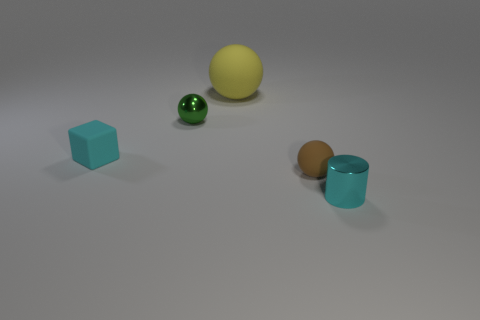Is the color of the sphere behind the green metallic thing the same as the cube?
Provide a succinct answer. No. What color is the sphere that is both on the right side of the green metallic object and behind the tiny block?
Provide a succinct answer. Yellow. What is the tiny cyan object that is in front of the tiny cyan matte thing made of?
Provide a short and direct response. Metal. The brown object has what size?
Keep it short and to the point. Small. How many green things are either tiny matte balls or big objects?
Make the answer very short. 0. What size is the shiny object that is on the left side of the small cyan thing right of the large yellow rubber sphere?
Your response must be concise. Small. Do the metallic cylinder and the tiny metallic object that is on the left side of the cylinder have the same color?
Offer a very short reply. No. What number of other things are there of the same material as the cylinder
Offer a very short reply. 1. There is a small cyan object that is the same material as the green thing; what shape is it?
Your response must be concise. Cylinder. Is there any other thing of the same color as the rubber cube?
Your response must be concise. Yes. 